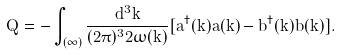Convert formula to latex. <formula><loc_0><loc_0><loc_500><loc_500>\hat { Q } = - \int _ { ( \infty ) } \frac { d ^ { 3 } \vec { k } } { ( 2 \pi ) ^ { 3 } 2 \omega ( \vec { k } ) } [ a ^ { \dagger } ( \vec { k } ) a ( \vec { k } ) - b ^ { \dagger } ( \vec { k } ) b ( \vec { k } ) ] .</formula> 